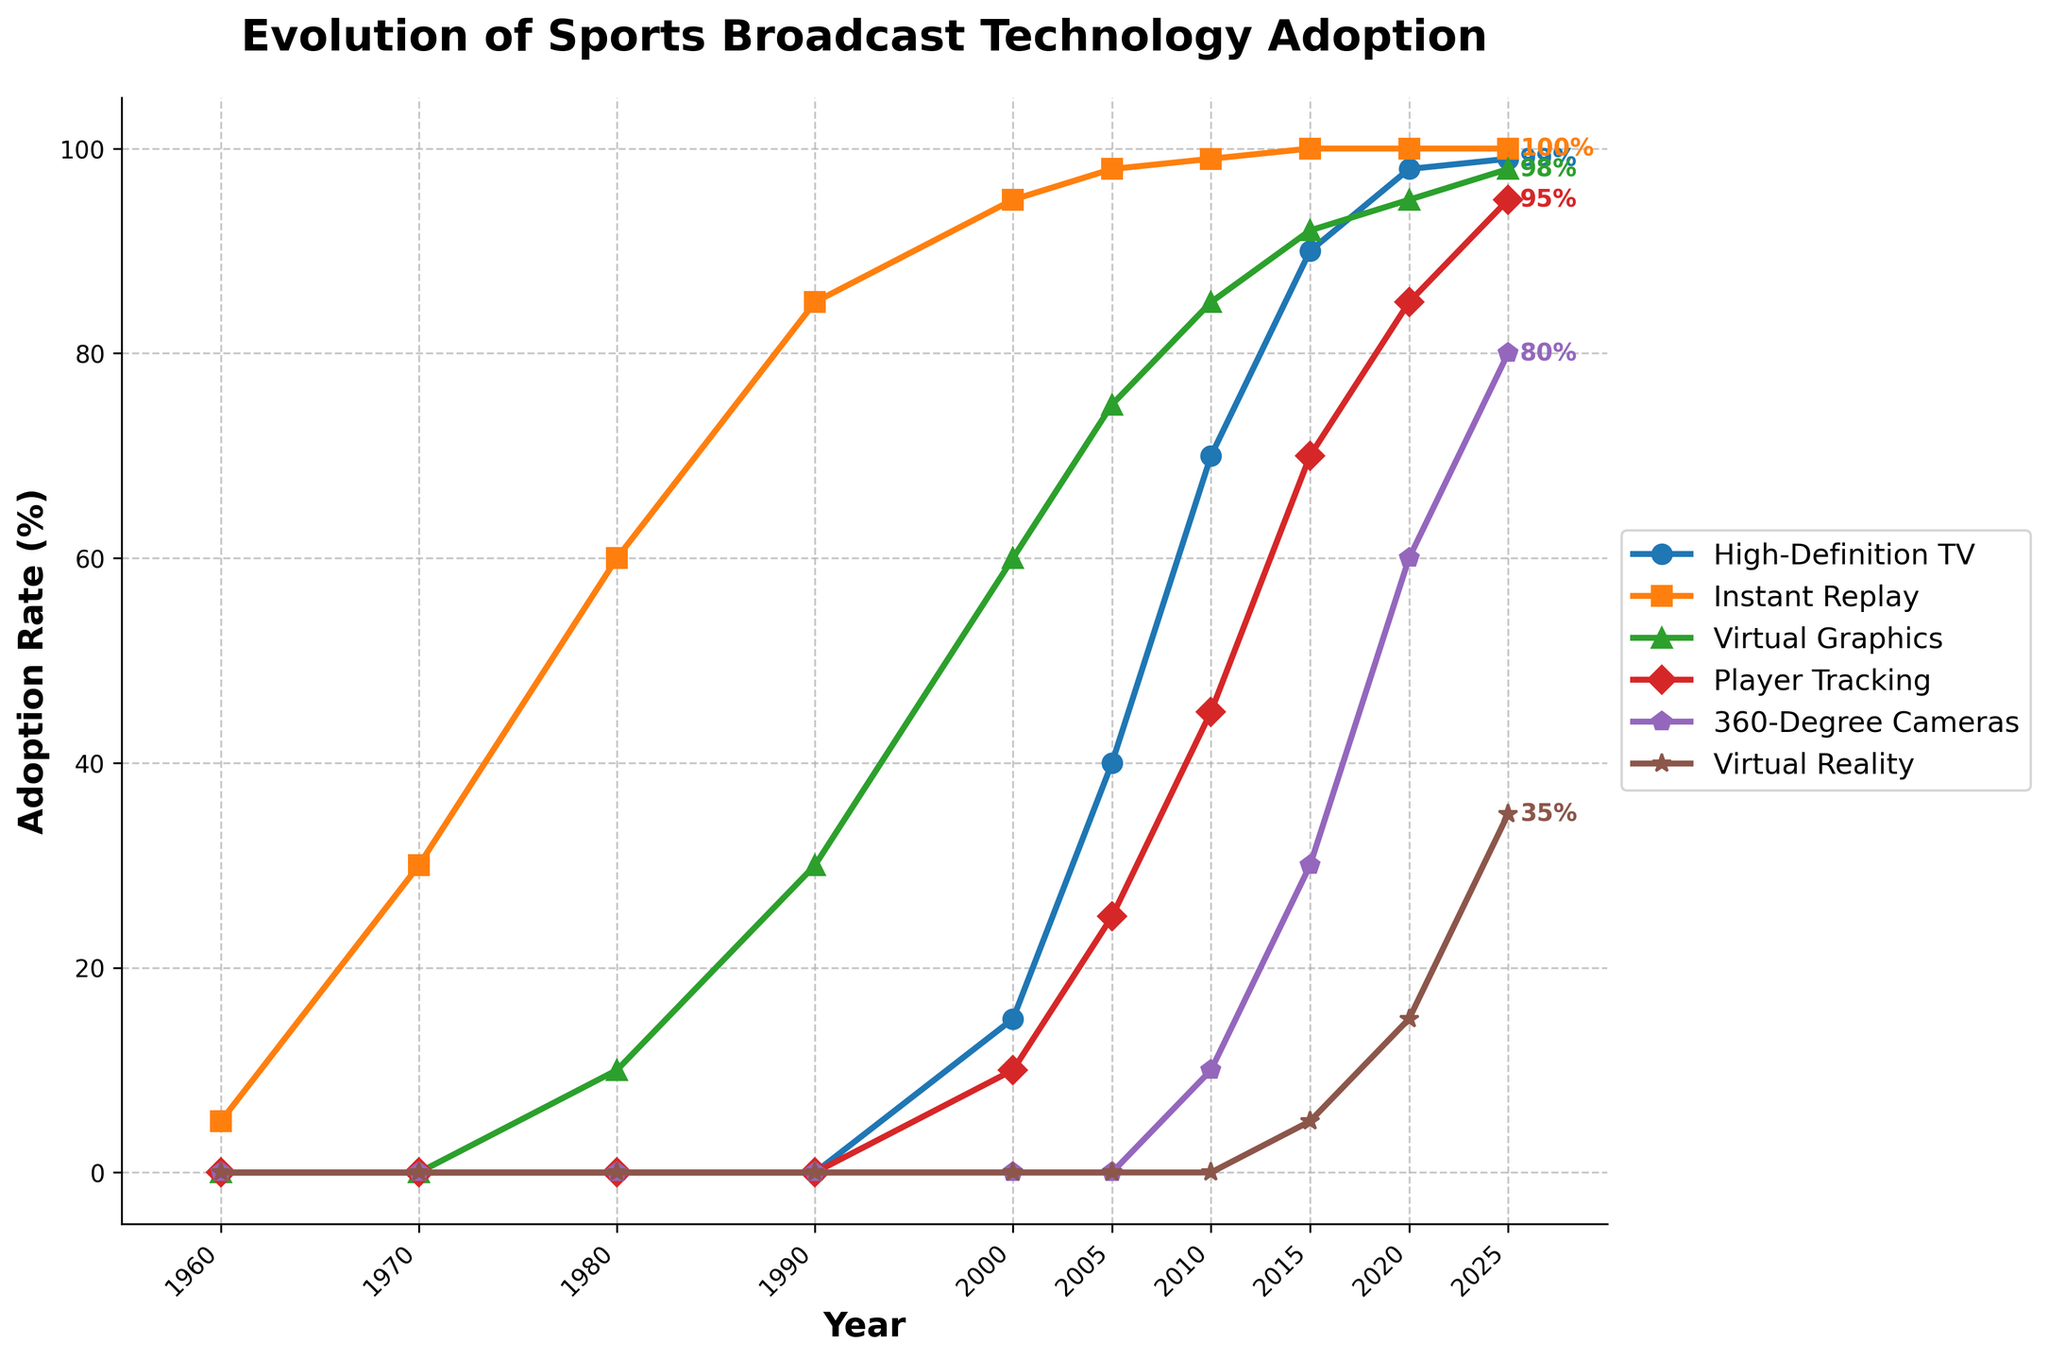Which technology had the highest adoption rate in 2025? Look at the endpoints in 2025. Instant Replay has an adoption rate of 100%, which is the highest among all technologies.
Answer: Instant Replay What was the adoption rate of High-Definition TV in 2005? Look at the value on the High-Definition TV line at 2005, which is 40%.
Answer: 40% Which technology showed the latest start in adoption? Identify the technology that has a flat line at 0 for the most extended period before increasing, which is Virtual Reality not starting until close to 2015.
Answer: Virtual Reality What's the difference in adoption rates between Virtual Graphics and Player Tracking in 2010? In 2010, Virtual Graphics have an adoption rate of 85% and Player Tracking have 45%. The difference is 85% - 45% = 40%.
Answer: 40% In which year did Instant Replay reach an adoption rate of 95%? Follow the Instant Replay line until it hits 95%, which occurs in 2000.
Answer: 2000 Compare the adoption rate of 360-Degree Cameras and Virtual Reality in 2020. Which is higher? Find the values in 2020 for both lines. 360-Degree Cameras have 60% and Virtual Reality has 15%. 360-Degree Cameras' adoption rate is higher.
Answer: 360-Degree Cameras What is the average adoption rate of Virtual Graphics over all years shown? Sum all Virtual Graphics points (0 + 0 + 10 + 30 + 60 + 75 + 85 + 92 + 95 + 98 = 545) and divide by the number of years (10). The average is 545 / 10 = 54.5%.
Answer: 54.5% Which technology had the steepest increase in adoption between 2000 and 2010? Calculate the adoption rate difference for each technology between 2000 and 2010, then find the largest. High-Definition TV: 70-15=55, Instant Replay: 99-95=4, Virtual Graphics: 85-60=25, Player Tracking: 45-10=35, 360-Degree Cameras: 10-0=10, Virtual Reality is not applicable. High-Definition TV has the steepest increase with 55%.
Answer: High-Definition TV What was the adoption rate of Player Tracking in 2015? Look at the value on the Player Tracking line at 2015, which is 70%.
Answer: 70% Which two technologies had equal adoption rates in 2015? Check each line at 2015 and find overlaps. 360-Degree Cameras and Virtual Reality do not apply, High-Definition TV: 90%, Instant Replay: 100%, Virtual Graphics: 92%, Player Tracking: 70%. No overlap is present.
Answer: None 